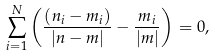Convert formula to latex. <formula><loc_0><loc_0><loc_500><loc_500>\sum ^ { N } _ { i = 1 } \left ( \frac { ( n _ { i } - m _ { i } ) } { | n - m | } - \frac { m _ { i } } { | m | } \right ) = 0 ,</formula> 